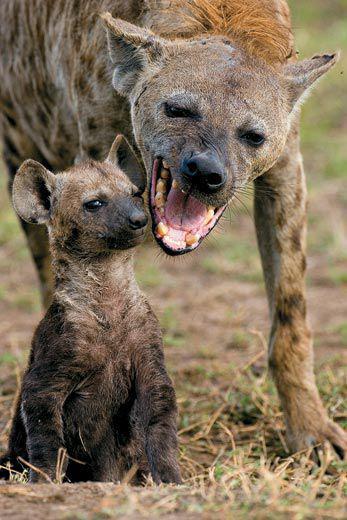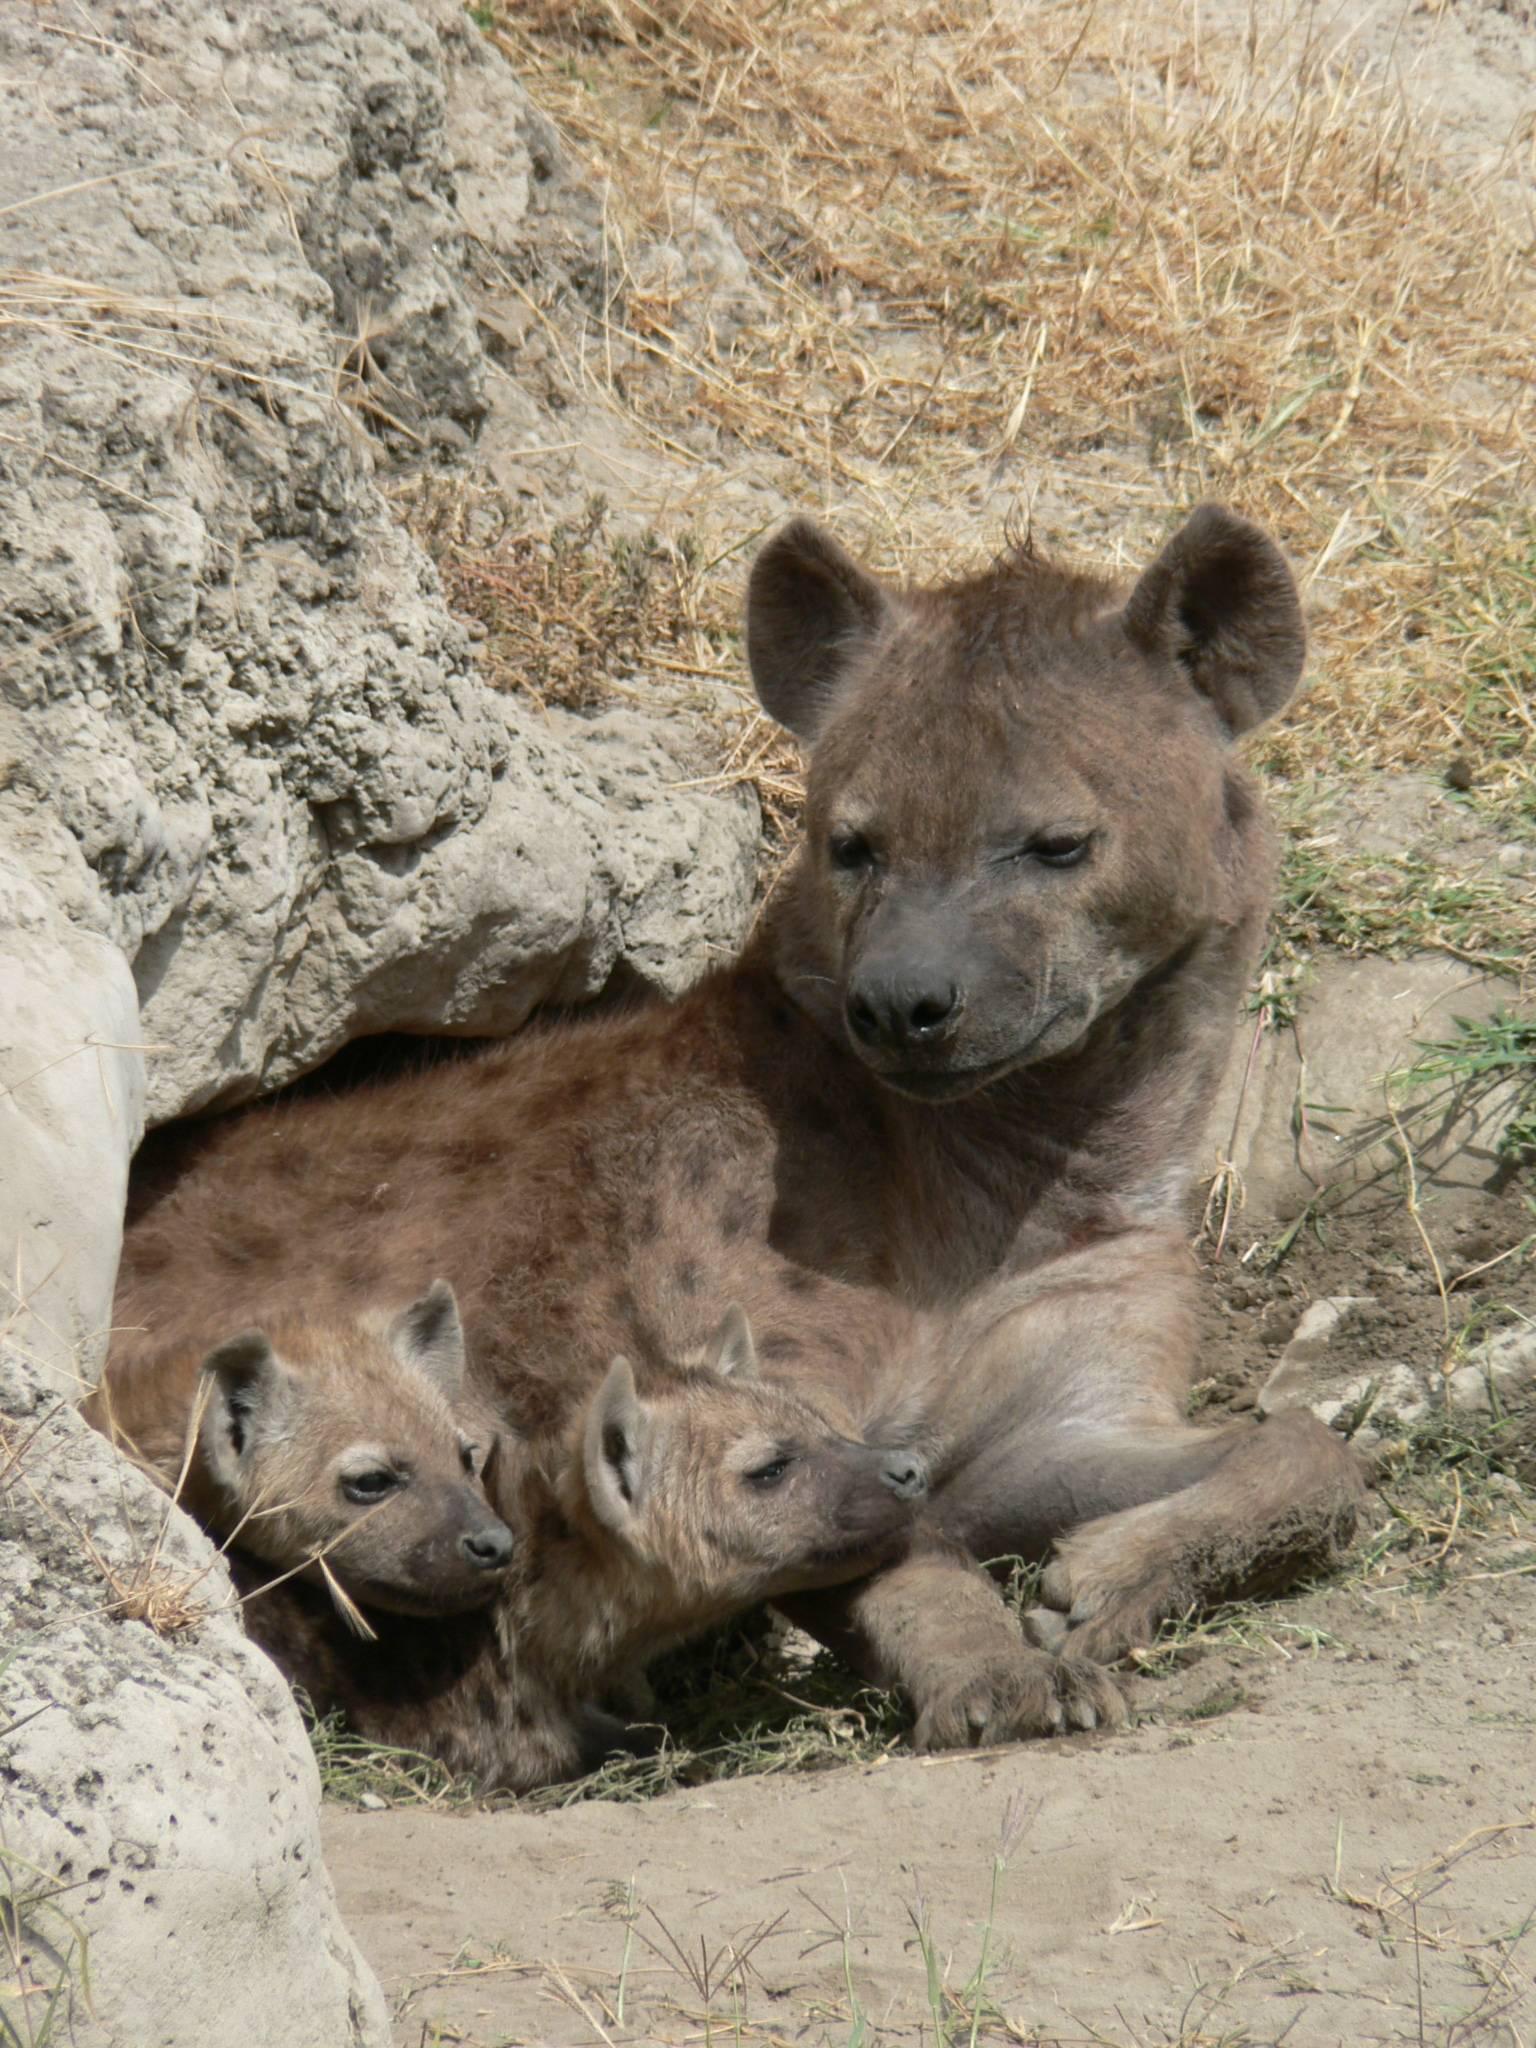The first image is the image on the left, the second image is the image on the right. For the images displayed, is the sentence "There is at least one pup present." factually correct? Answer yes or no. Yes. 